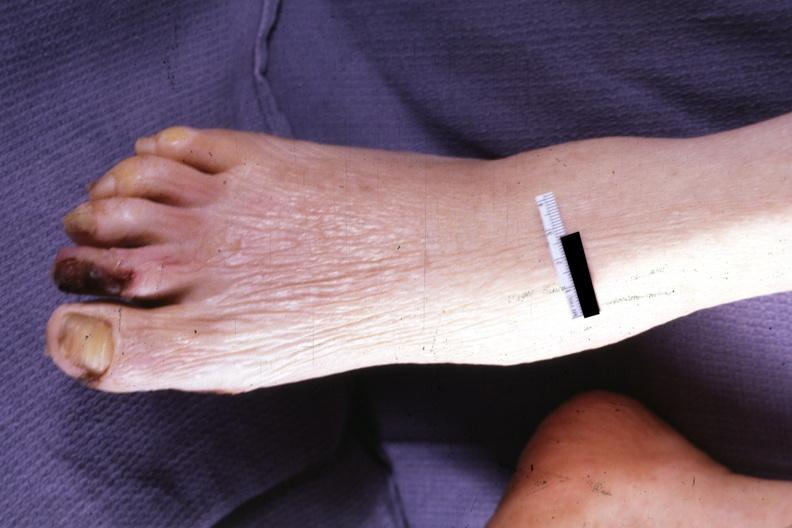re aldactone bodies present?
Answer the question using a single word or phrase. No 